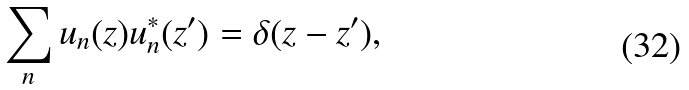Convert formula to latex. <formula><loc_0><loc_0><loc_500><loc_500>\sum _ { n } u _ { n } ( z ) u _ { n } ^ { * } ( z ^ { \prime } ) = \delta ( z - z ^ { \prime } ) ,</formula> 